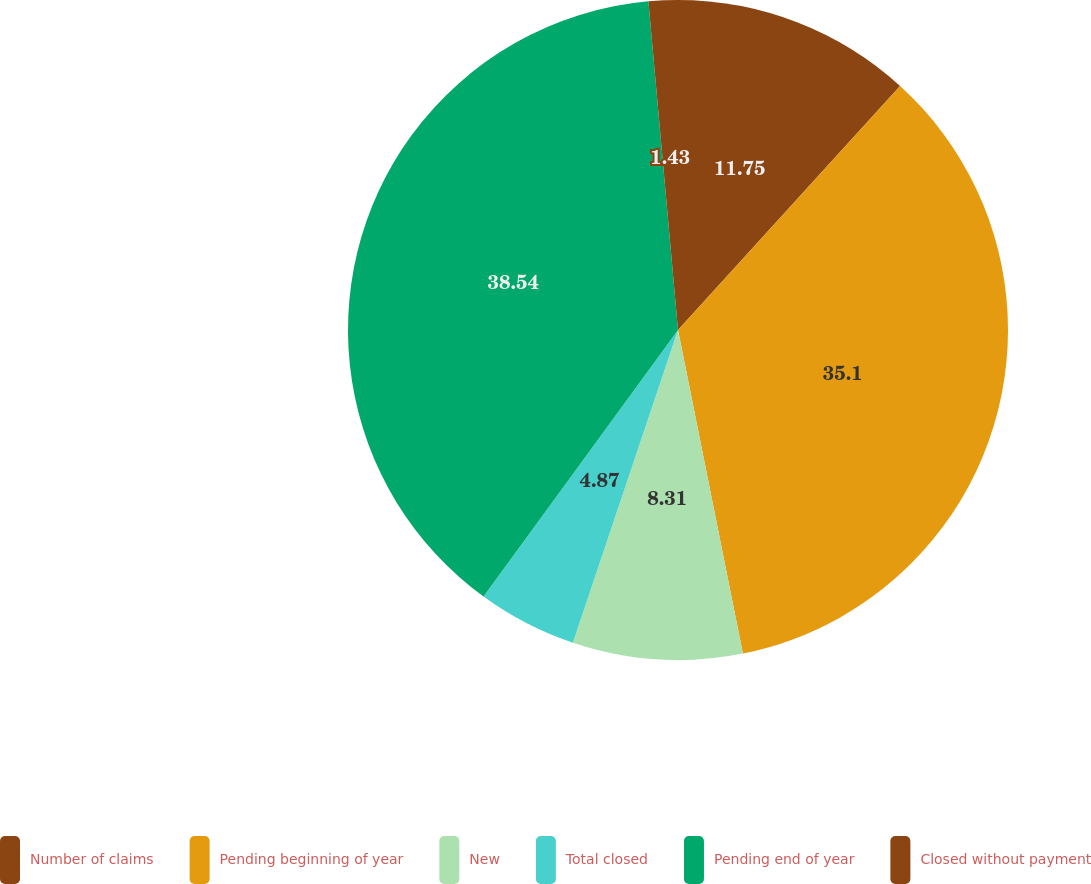<chart> <loc_0><loc_0><loc_500><loc_500><pie_chart><fcel>Number of claims<fcel>Pending beginning of year<fcel>New<fcel>Total closed<fcel>Pending end of year<fcel>Closed without payment<nl><fcel>11.75%<fcel>35.1%<fcel>8.31%<fcel>4.87%<fcel>38.54%<fcel>1.43%<nl></chart> 